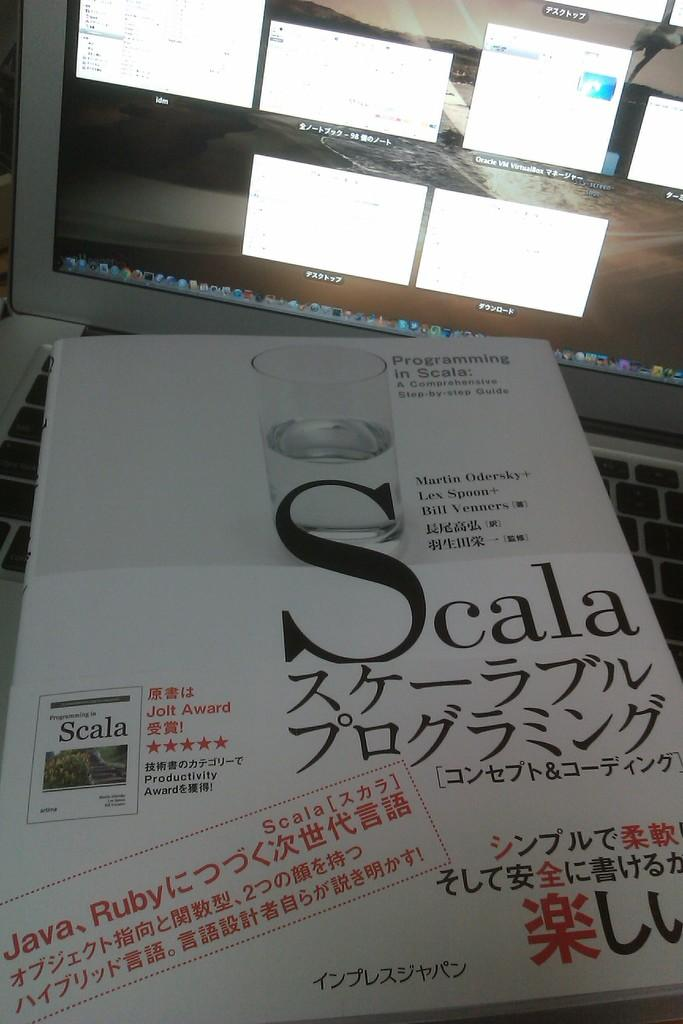<image>
Share a concise interpretation of the image provided. Programming in Scala: A Comprehensive step by step guide book. 